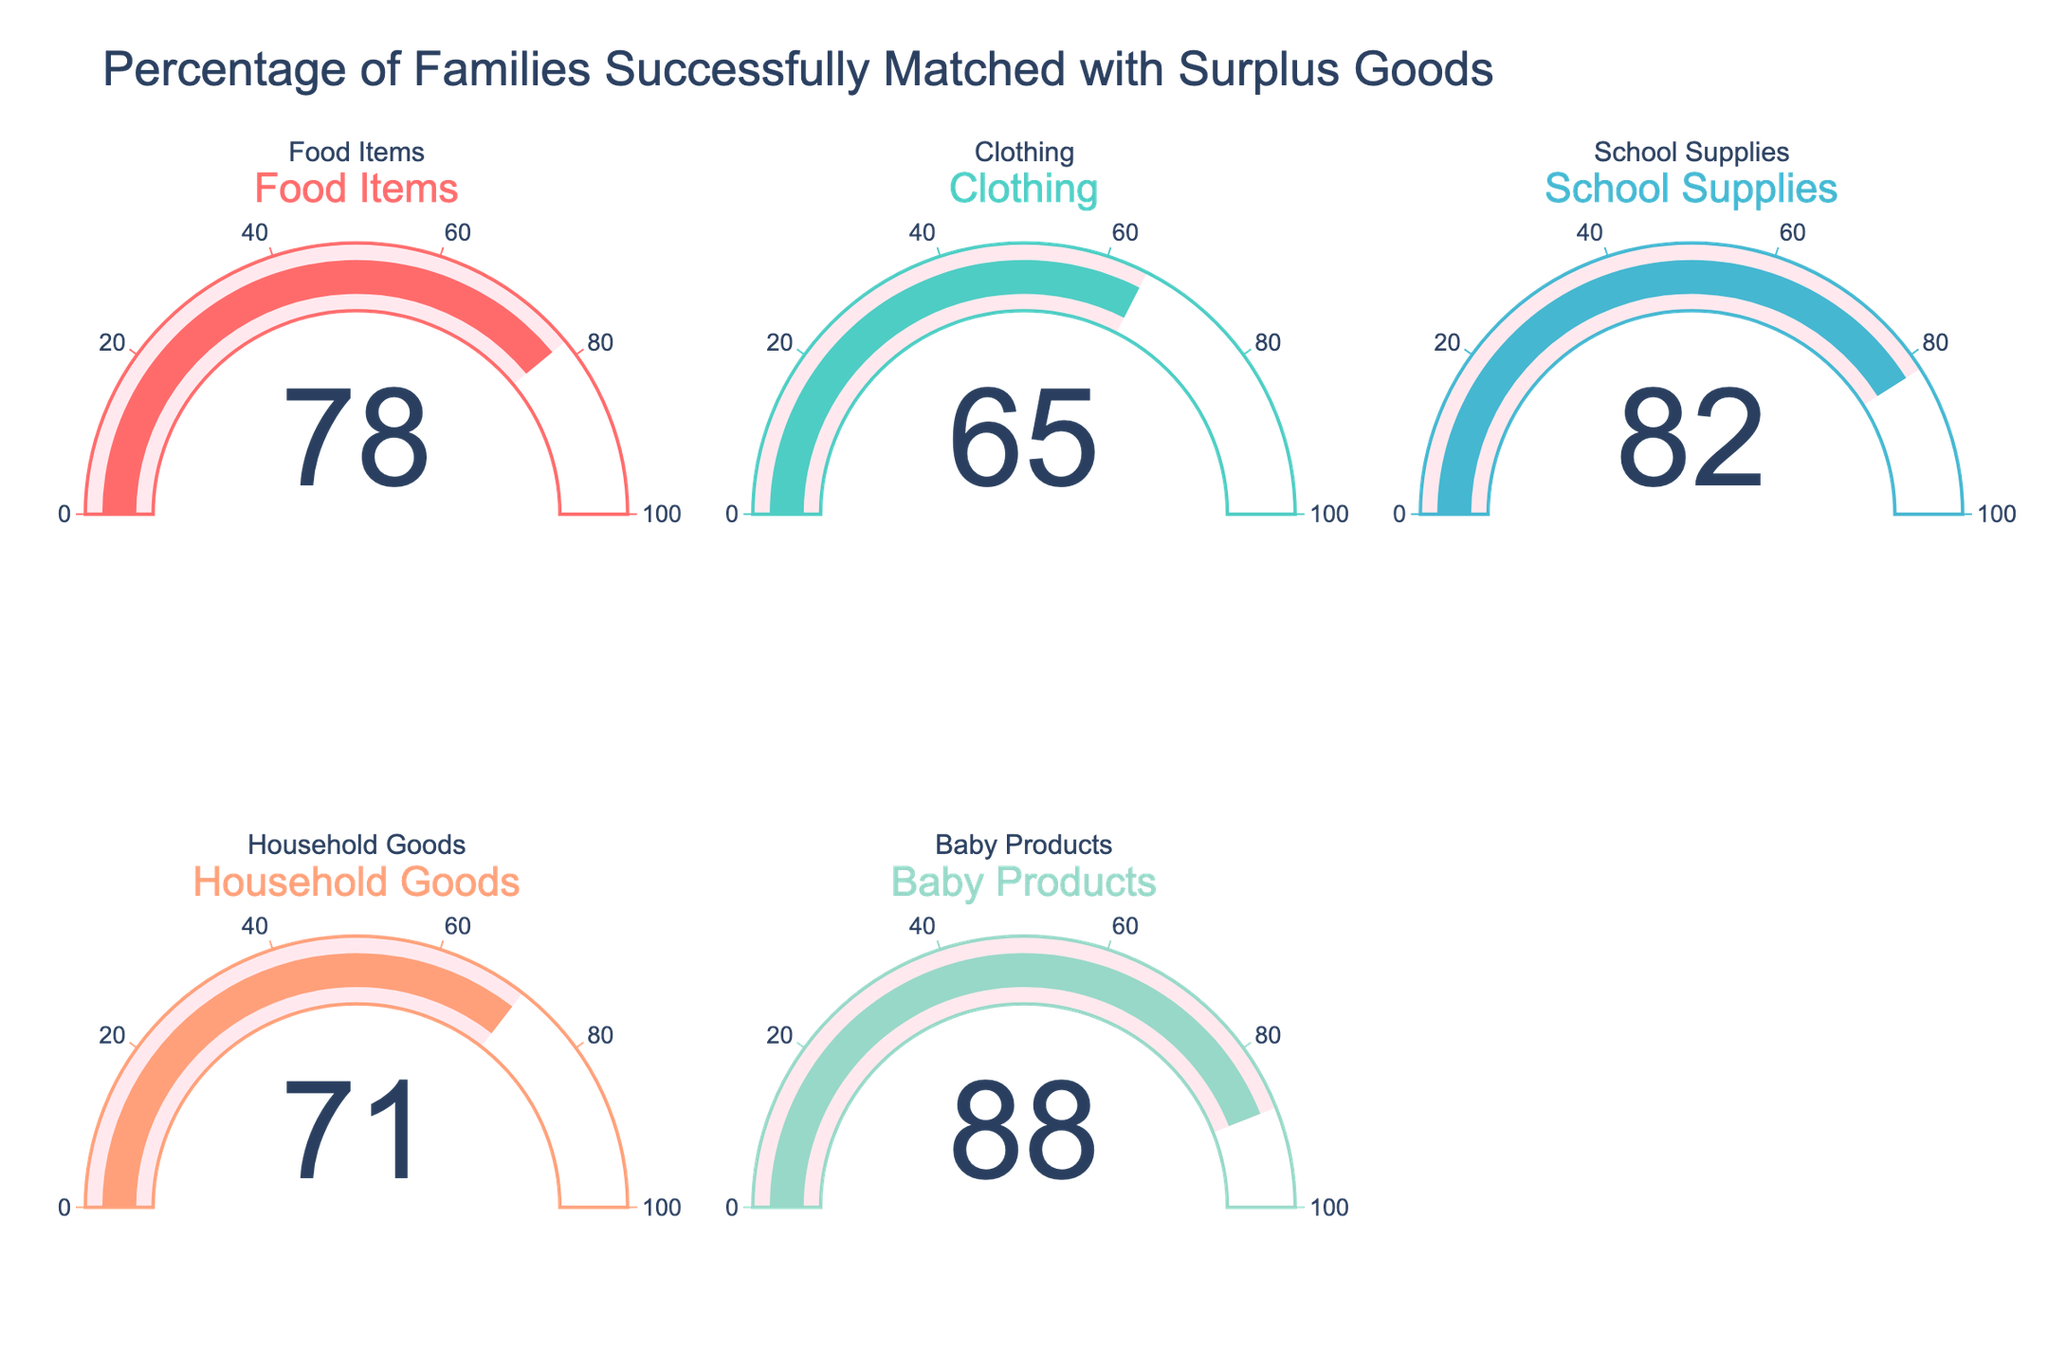What's the title of the figure? The title of the figure is typically displayed prominently at the top. By looking at the top part of the figure, we can see that the title reads, "Percentage of Families Successfully Matched with Surplus Goods".
Answer: Percentage of Families Successfully Matched with Surplus Goods Which category has the highest percentage of families matched with surplus goods? Looking at all the gauges in the figure, we can identify the one with the highest percentage. The gauge for Baby Products shows the highest percentage at 88.
Answer: Baby Products What's the mean percentage of families matched across all categories? To find the mean percentage, add up all the percentages and then divide by the number of categories. The percentages are 78, 65, 82, 71, and 88. Sum them up to get 384, then divide by 5 (the number of categories): 384/5 equals 76.8.
Answer: 76.8 How does the percentage of families matched for Clothing compare to that for Household Goods? By comparing their respective percentages, the gauge for Clothing shows 65 while Household Goods shows 71. Since 65 is less than 71, the percentage for Clothing is lower than for Household Goods.
Answer: Clothing is lower What percentage of families were matched with school supplies? The figure includes gauges for each category with the associated percentages. The gauge for School Supplies shows 82, indicating that 82% of families were matched with school supplies.
Answer: 82 Which category has the lowest percentage of families matched? Reviewing all the gauge percentages, Clothing has the lowest percentage at 65.
Answer: Clothing By how many percentage points does the matching rate for Baby Products exceed the matching rate for Food Items? Subtract the percentage for Food Items from the percentage for Baby Products. The Baby Products gauge reads 88, and the Food Items gauge reads 78. The difference is 88 minus 78, yielding 10 percentage points.
Answer: 10 Combine the percentages of matched families for Food Items and Clothing, then what's the difference in percentage compared to Baby Products? Adding the percentages for Food Items (78) and Clothing (65) gives 143. The difference between this sum and the percentage for Baby Products (88) is found by subtracting 88 from 143, which is 55 percentage points.
Answer: 55 What's the range of percentages shown in the figure? The range of the data is calculated by subtracting the lowest value from the highest value. The lowest percentage is 65 (Clothing), and the highest is 88 (Baby Products), so the range is 88 minus 65, which is 23 percentage points.
Answer: 23 